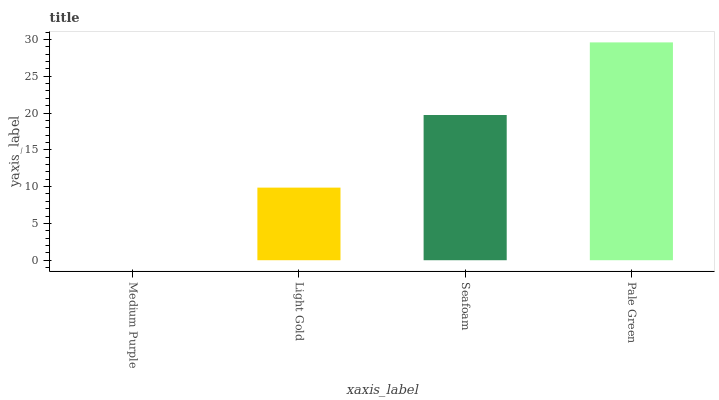Is Medium Purple the minimum?
Answer yes or no. Yes. Is Pale Green the maximum?
Answer yes or no. Yes. Is Light Gold the minimum?
Answer yes or no. No. Is Light Gold the maximum?
Answer yes or no. No. Is Light Gold greater than Medium Purple?
Answer yes or no. Yes. Is Medium Purple less than Light Gold?
Answer yes or no. Yes. Is Medium Purple greater than Light Gold?
Answer yes or no. No. Is Light Gold less than Medium Purple?
Answer yes or no. No. Is Seafoam the high median?
Answer yes or no. Yes. Is Light Gold the low median?
Answer yes or no. Yes. Is Light Gold the high median?
Answer yes or no. No. Is Medium Purple the low median?
Answer yes or no. No. 